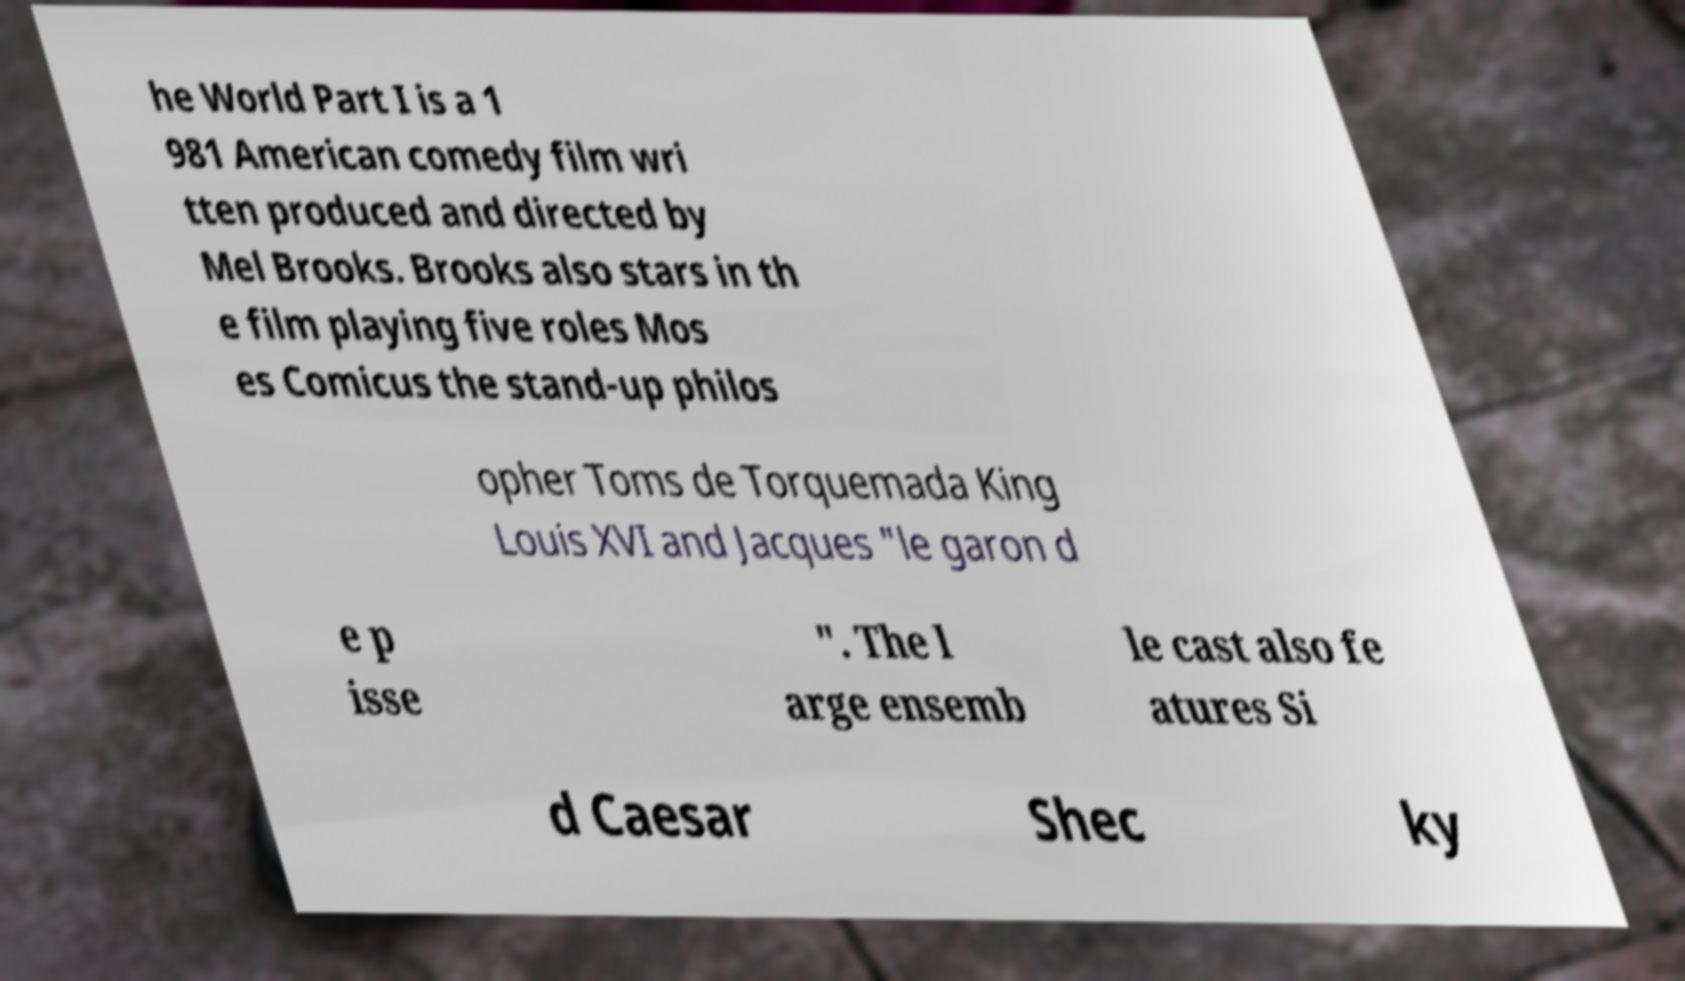Can you read and provide the text displayed in the image?This photo seems to have some interesting text. Can you extract and type it out for me? he World Part I is a 1 981 American comedy film wri tten produced and directed by Mel Brooks. Brooks also stars in th e film playing five roles Mos es Comicus the stand-up philos opher Toms de Torquemada King Louis XVI and Jacques "le garon d e p isse ". The l arge ensemb le cast also fe atures Si d Caesar Shec ky 